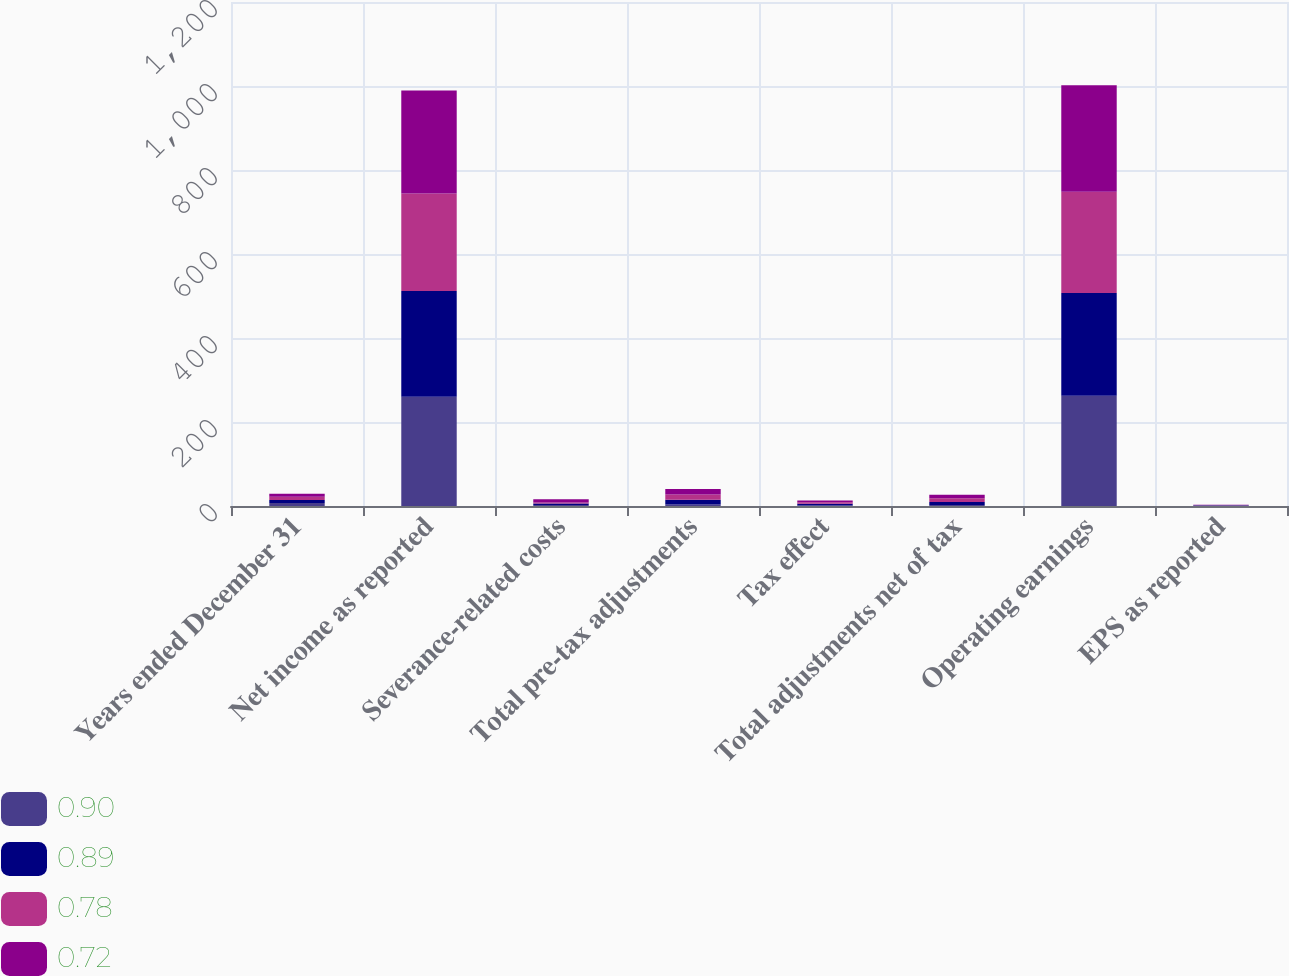Convert chart. <chart><loc_0><loc_0><loc_500><loc_500><stacked_bar_chart><ecel><fcel>Years ended December 31<fcel>Net income as reported<fcel>Severance-related costs<fcel>Total pre-tax adjustments<fcel>Tax effect<fcel>Total adjustments net of tax<fcel>Operating earnings<fcel>EPS as reported<nl><fcel>0.9<fcel>7.25<fcel>260.1<fcel>2.4<fcel>3.7<fcel>1.3<fcel>2.4<fcel>262.5<fcel>0.86<nl><fcel>0.89<fcel>7.25<fcel>251.7<fcel>3.3<fcel>11.1<fcel>3.9<fcel>7.2<fcel>244.5<fcel>0.84<nl><fcel>0.78<fcel>7.25<fcel>232.4<fcel>2.8<fcel>12.7<fcel>4<fcel>8.7<fcel>241.1<fcel>0.74<nl><fcel>0.72<fcel>7.25<fcel>245.3<fcel>7.3<fcel>12.7<fcel>4.1<fcel>8.6<fcel>253.9<fcel>0.72<nl></chart> 